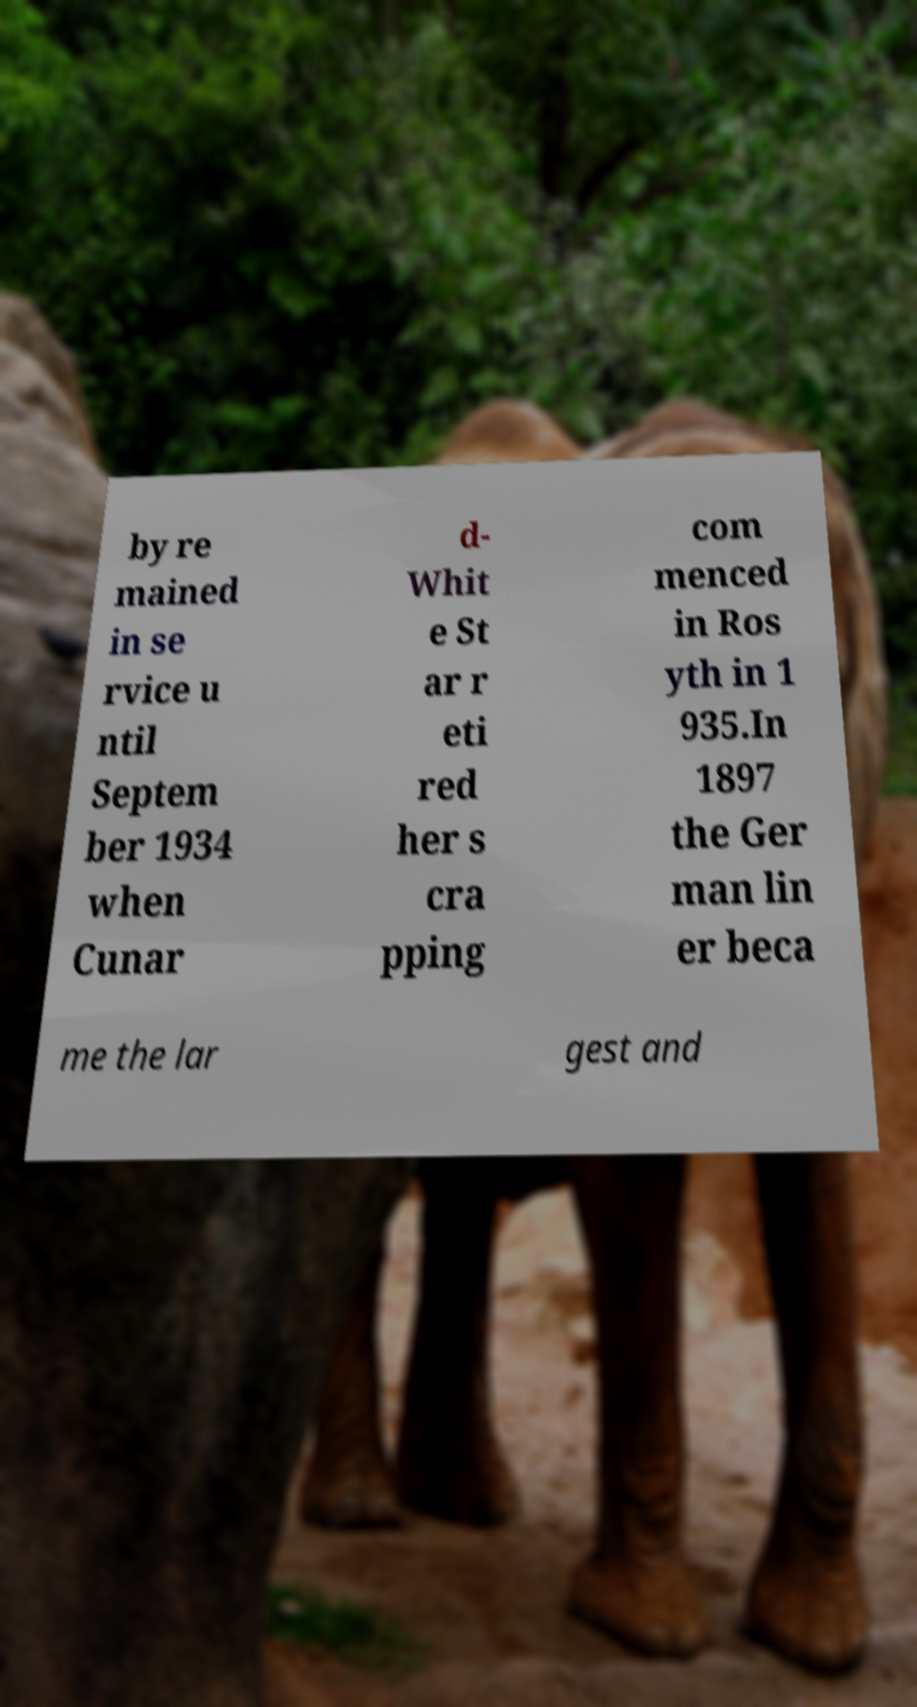Could you extract and type out the text from this image? by re mained in se rvice u ntil Septem ber 1934 when Cunar d- Whit e St ar r eti red her s cra pping com menced in Ros yth in 1 935.In 1897 the Ger man lin er beca me the lar gest and 